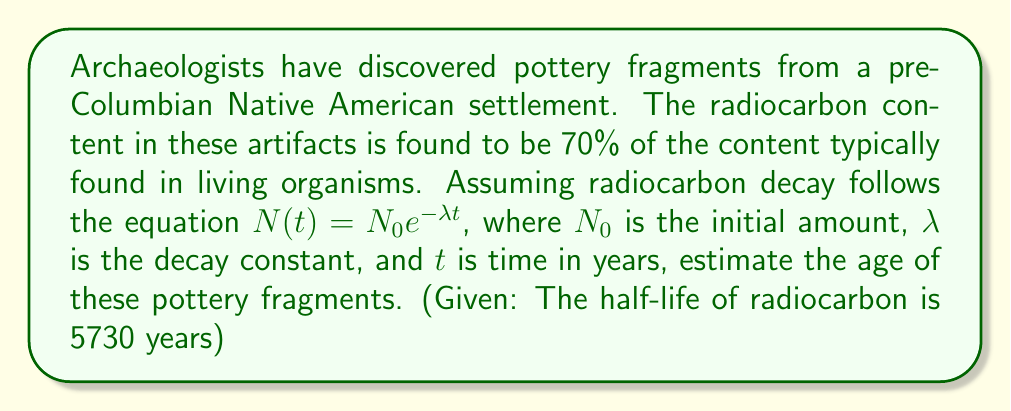Teach me how to tackle this problem. To solve this problem, we'll follow these steps:

1) First, we need to find the decay constant $\lambda$ using the half-life:

   At half-life, $N(t) = \frac{1}{2}N_0$

   $\frac{1}{2}N_0 = N_0e^{-\lambda t_{1/2}}$

   $\frac{1}{2} = e^{-\lambda t_{1/2}}$

   $\ln(\frac{1}{2}) = -\lambda t_{1/2}$

   $\lambda = \frac{\ln(2)}{t_{1/2}} = \frac{\ln(2)}{5730} \approx 0.000121$ per year

2) Now, we can use the decay equation to find $t$:

   $N(t) = N_0e^{-\lambda t}$

   $0.70N_0 = N_0e^{-\lambda t}$

   $0.70 = e^{-\lambda t}$

3) Taking natural log of both sides:

   $\ln(0.70) = -\lambda t$

4) Solving for $t$:

   $t = -\frac{\ln(0.70)}{\lambda} = -\frac{\ln(0.70)}{0.000121}$

5) Calculate the result:

   $t \approx 2949$ years

Therefore, the pottery fragments are approximately 2949 years old.
Answer: The estimated age of the pottery fragments is approximately 2949 years. 